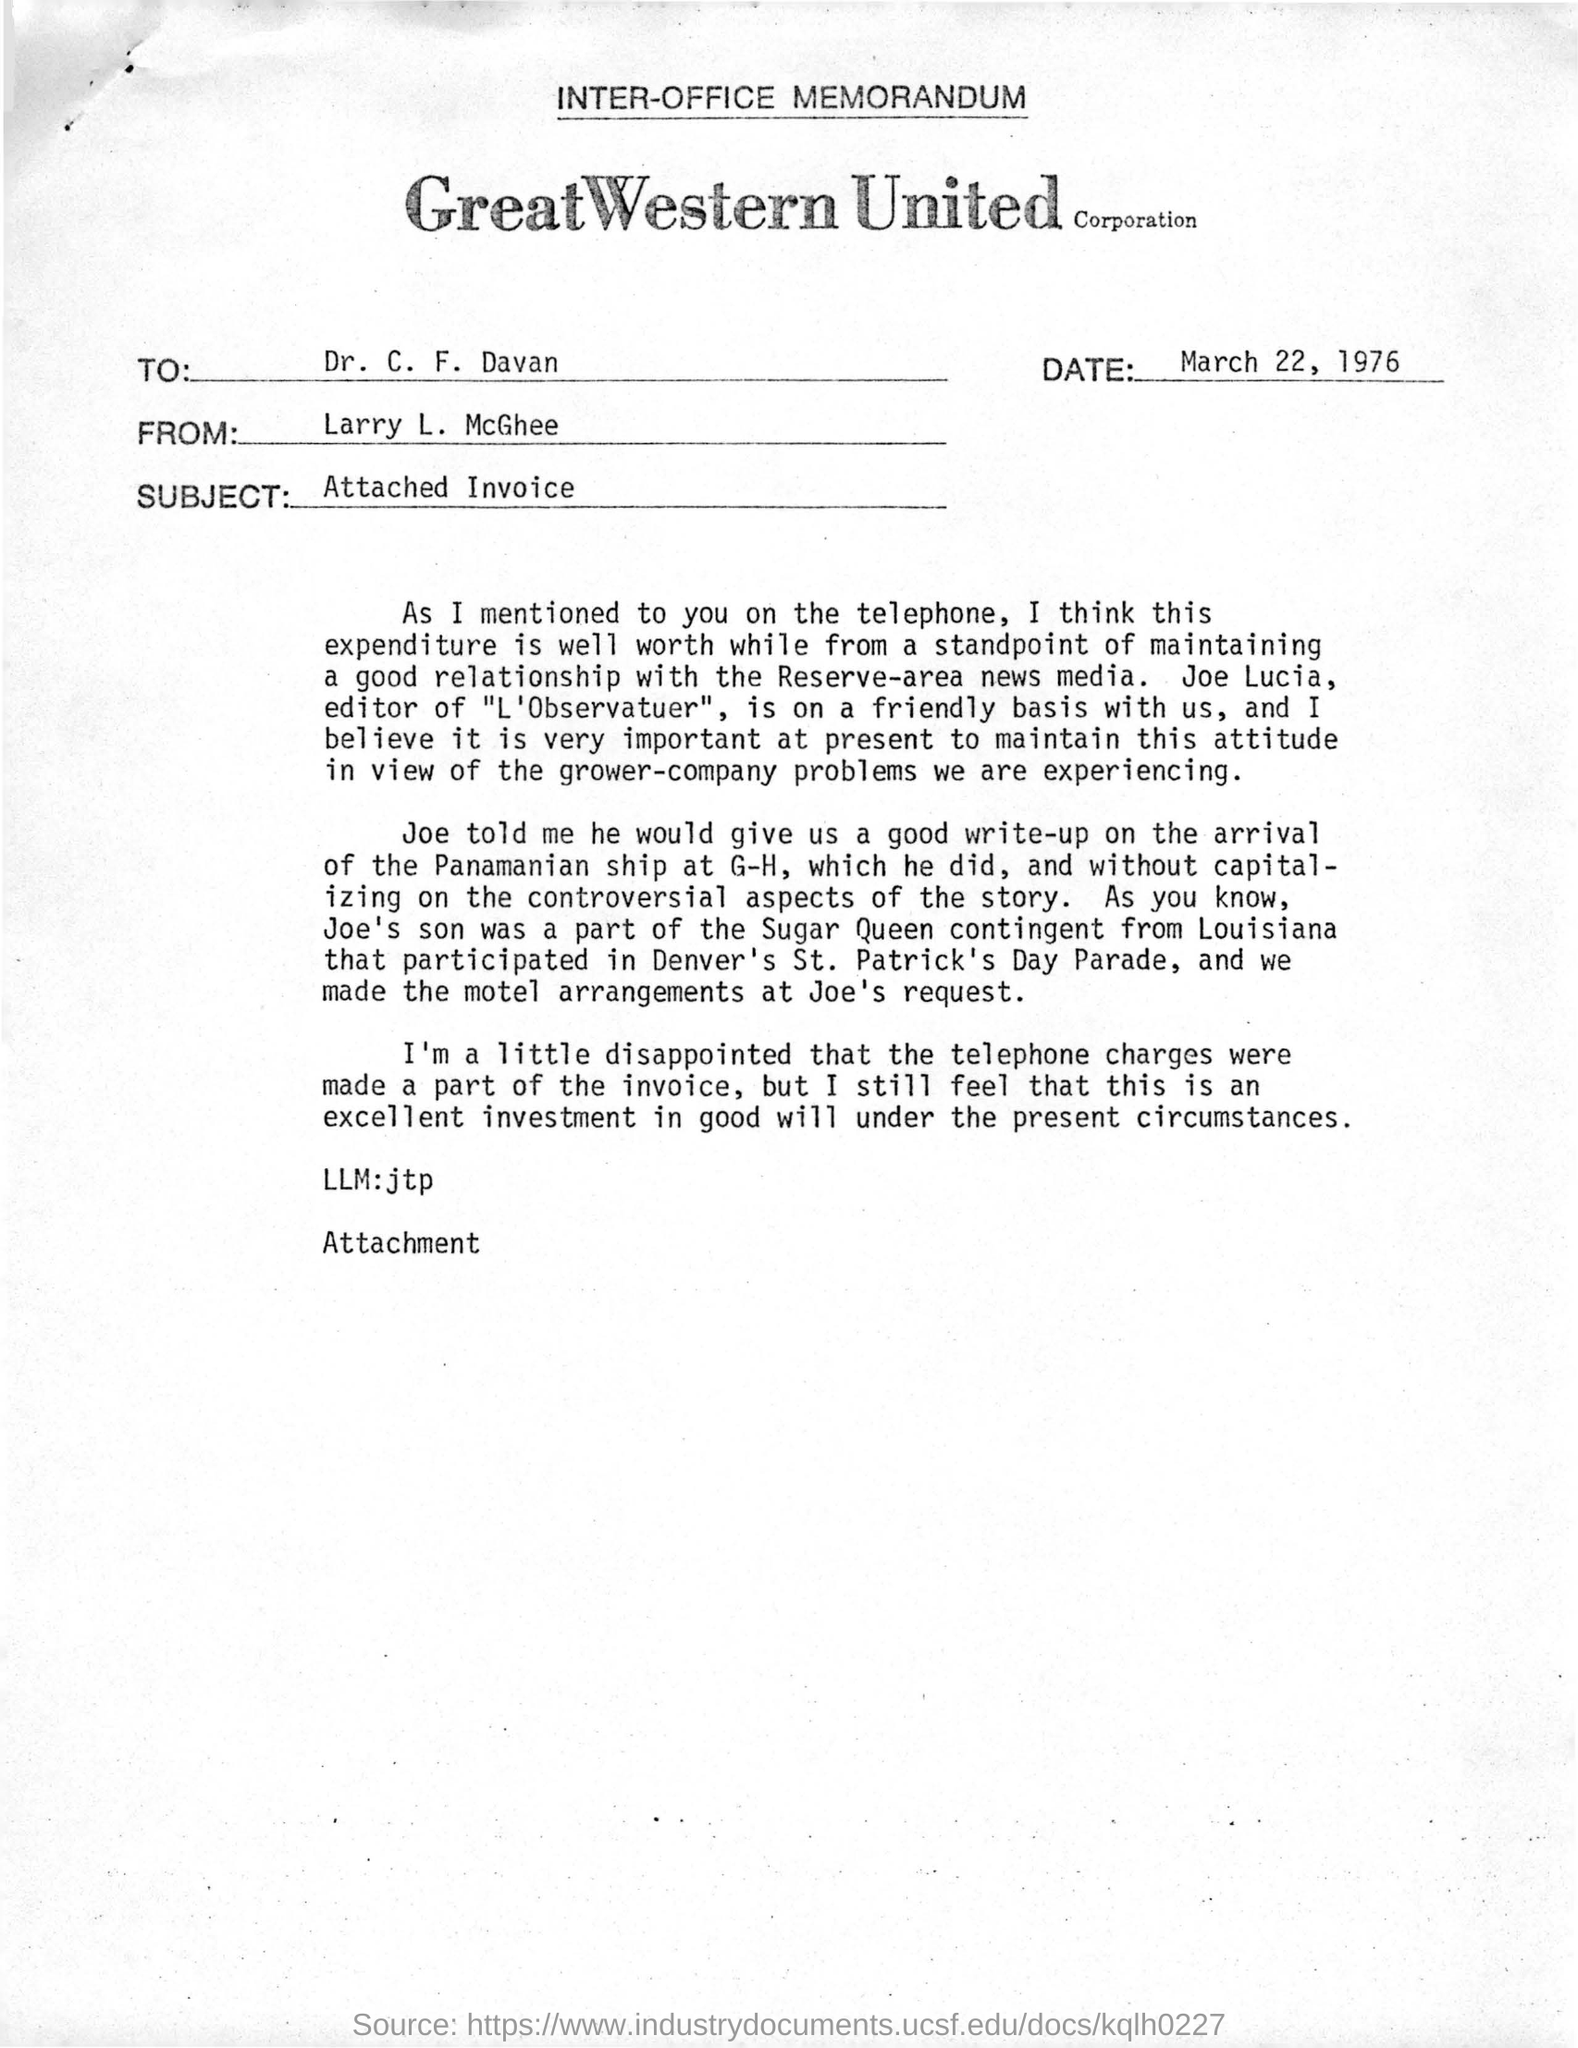Highlight a few significant elements in this photo. The sender in the document is Larry L. McGhee. The subject mentioned in this document is the attached Invoice. The document mentions a company called Great Western United Corporation. The date in the document is March 22, 1976. It is an inter-office memorandum. 